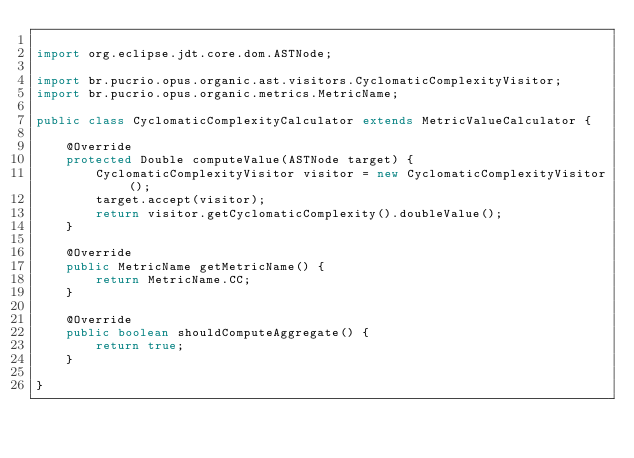<code> <loc_0><loc_0><loc_500><loc_500><_Java_>
import org.eclipse.jdt.core.dom.ASTNode;

import br.pucrio.opus.organic.ast.visitors.CyclomaticComplexityVisitor;
import br.pucrio.opus.organic.metrics.MetricName;

public class CyclomaticComplexityCalculator extends MetricValueCalculator {
	
	@Override
	protected Double computeValue(ASTNode target) {
		CyclomaticComplexityVisitor visitor = new CyclomaticComplexityVisitor();
		target.accept(visitor);
		return visitor.getCyclomaticComplexity().doubleValue();
	}

	@Override
	public MetricName getMetricName() {
		return MetricName.CC;
	}
	
	@Override
	public boolean shouldComputeAggregate() {
		return true;
	}

}
</code> 